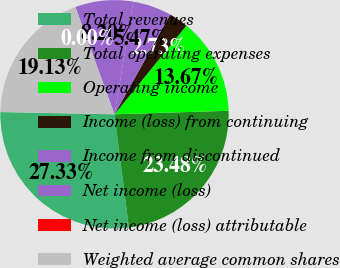Convert chart. <chart><loc_0><loc_0><loc_500><loc_500><pie_chart><fcel>Total revenues<fcel>Total operating expenses<fcel>Operating income<fcel>Income (loss) from continuing<fcel>Income from discontinued<fcel>Net income (loss)<fcel>Net income (loss) attributable<fcel>Weighted average common shares<nl><fcel>27.33%<fcel>23.48%<fcel>13.67%<fcel>2.73%<fcel>5.47%<fcel>8.2%<fcel>0.0%<fcel>19.13%<nl></chart> 